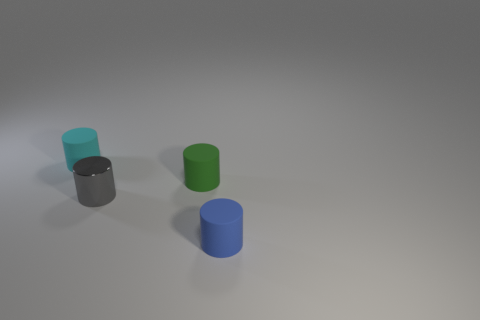Can you tell me the colors of all the cylinders in the image? Certainly! There are four cylinders in the image, each with a different color: cyan, green, black, and blue. 